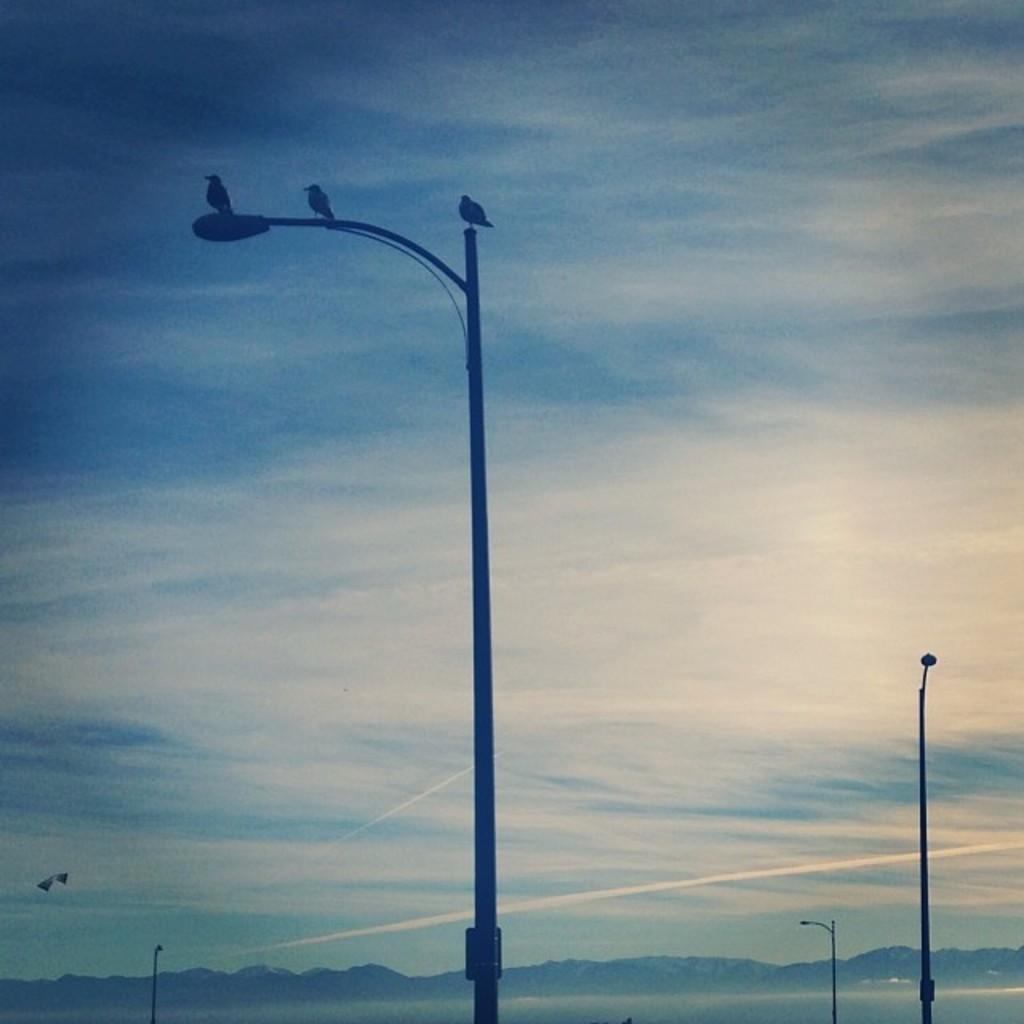Please provide a concise description of this image. In the image we can see light pole and on the light pole there are birds sitting, there is a cloudy sky. 